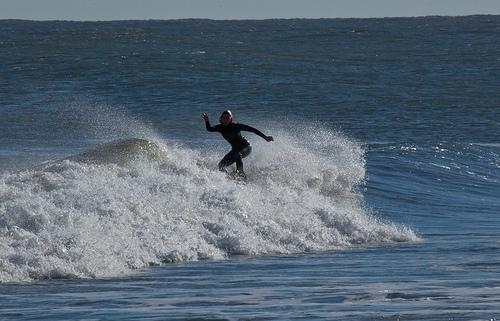Describe the color of the sky and the ocean. The sky is a light blue color with no clouds, and the ocean has various shades of blue depending on the scene details. How would you advertise this picture for a surfboard and wetsuit company? Ride the waves in style with our top-of-the-line surfboard and sleek black wetsuit, designed for balance, control, and ultimate performance. Experience the thrill today! Explain one of the techniques the person uses to maintain their balance while surfing. The person holds their arms wide apart to help maintain balance while riding the wave. Explain the movement of the water around the surfer in detail. The water around the surfer is churning and forming a wave that's crashing back into the ocean, with white foam, spray, and splashes. There are also ripples and calmer waters further away. What can you say about the sky and the water in this image? The sky is light blue and cloudless, while the water has various shades of blue with white foam and splashes. Can you make an assumption about the time of the day when this picture was taken? The picture was likely taken during daytime. Briefly explain what the person in the image is doing and what they are wearing. The person is surfing on a wave while wearing a black wetsuit and maintaining balance with their arms extended. Mention two characteristics of the person's appearance. The person has brown hair and is wearing a black wetsuit. Describe the environment around the person surfing in the image. The surfer is surrounded by a large wave churning around them, with ripples and calm blue water in the distance, under a light blue and cloudless sky. Which of the following sentences best describes the picture: 1) A person swimming in a pool, 2) A woman surfing on a wave, 3) A man kayaking in a river? A woman surfing on a wave. 